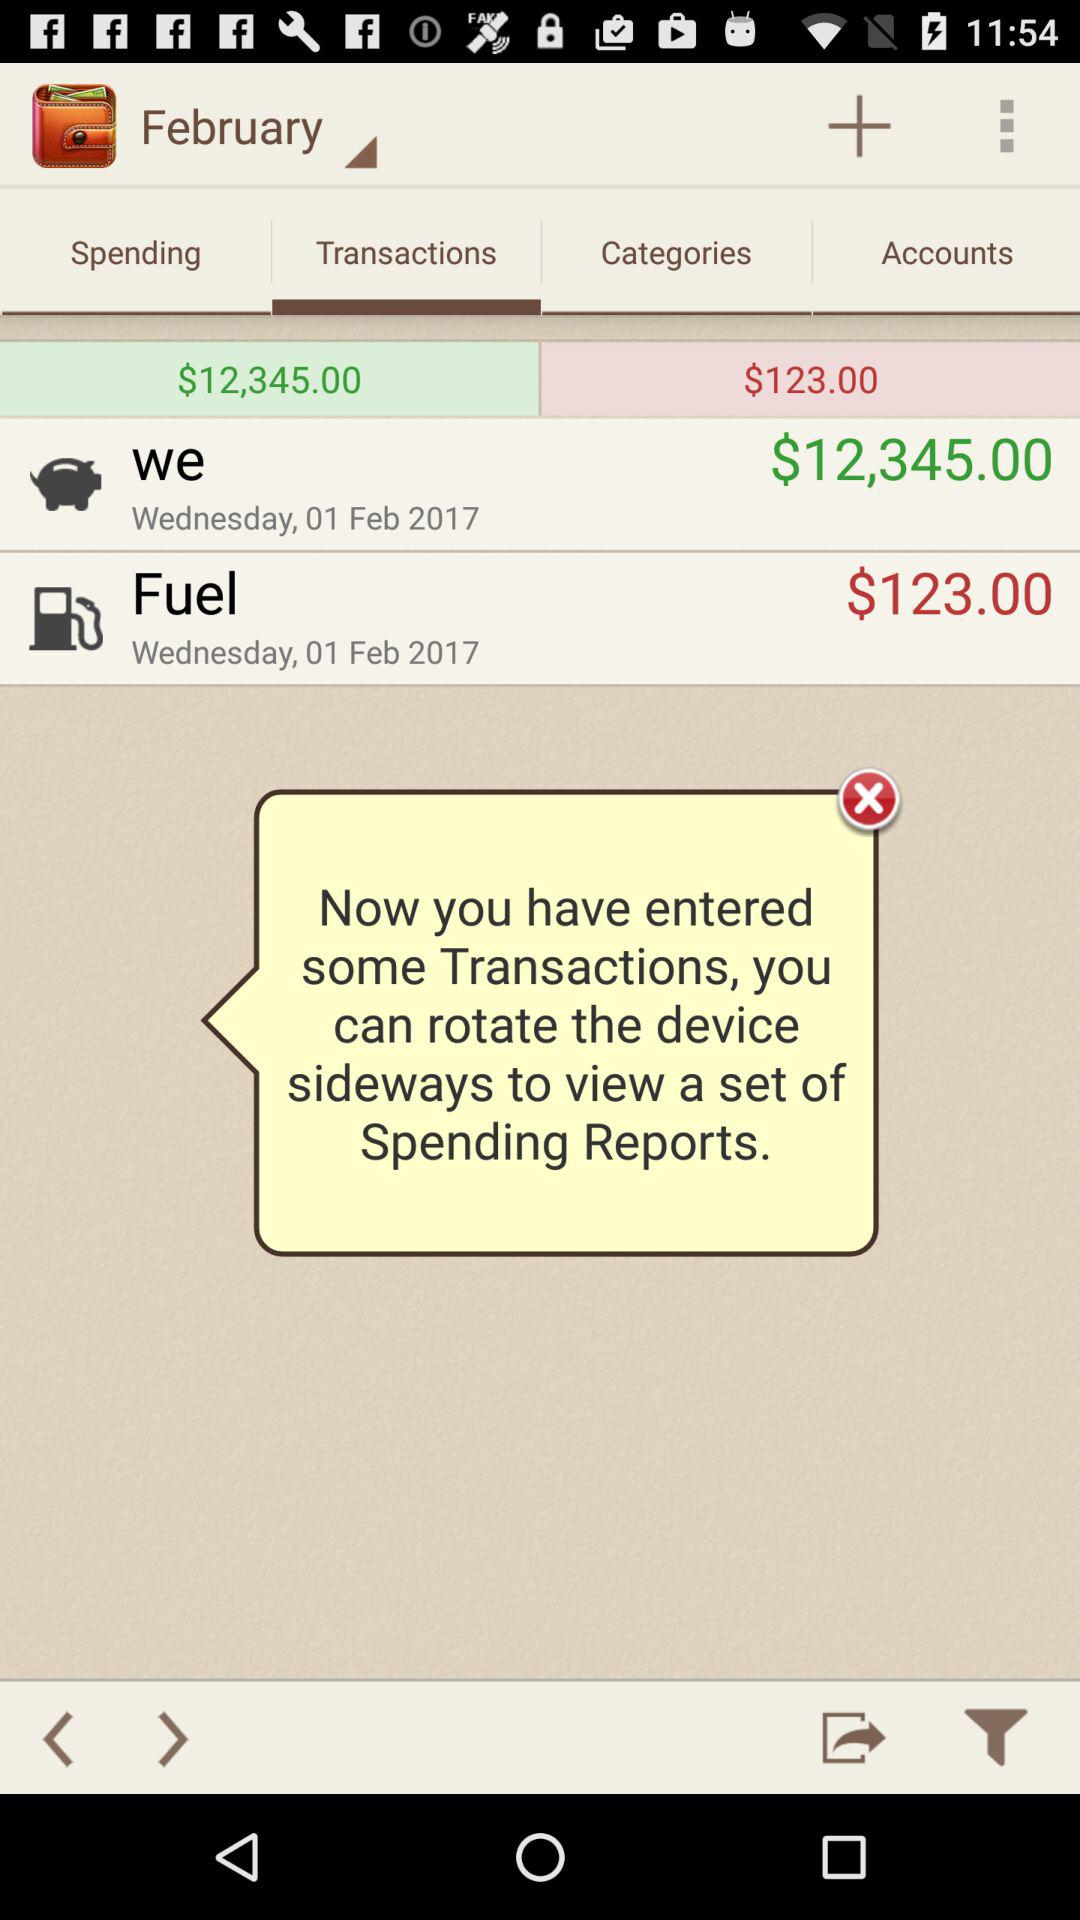On what date were the transactions "we" and "fuel" made? The transactions "we" and "fuel" were made on Wednesday, 01 February, 2017. 